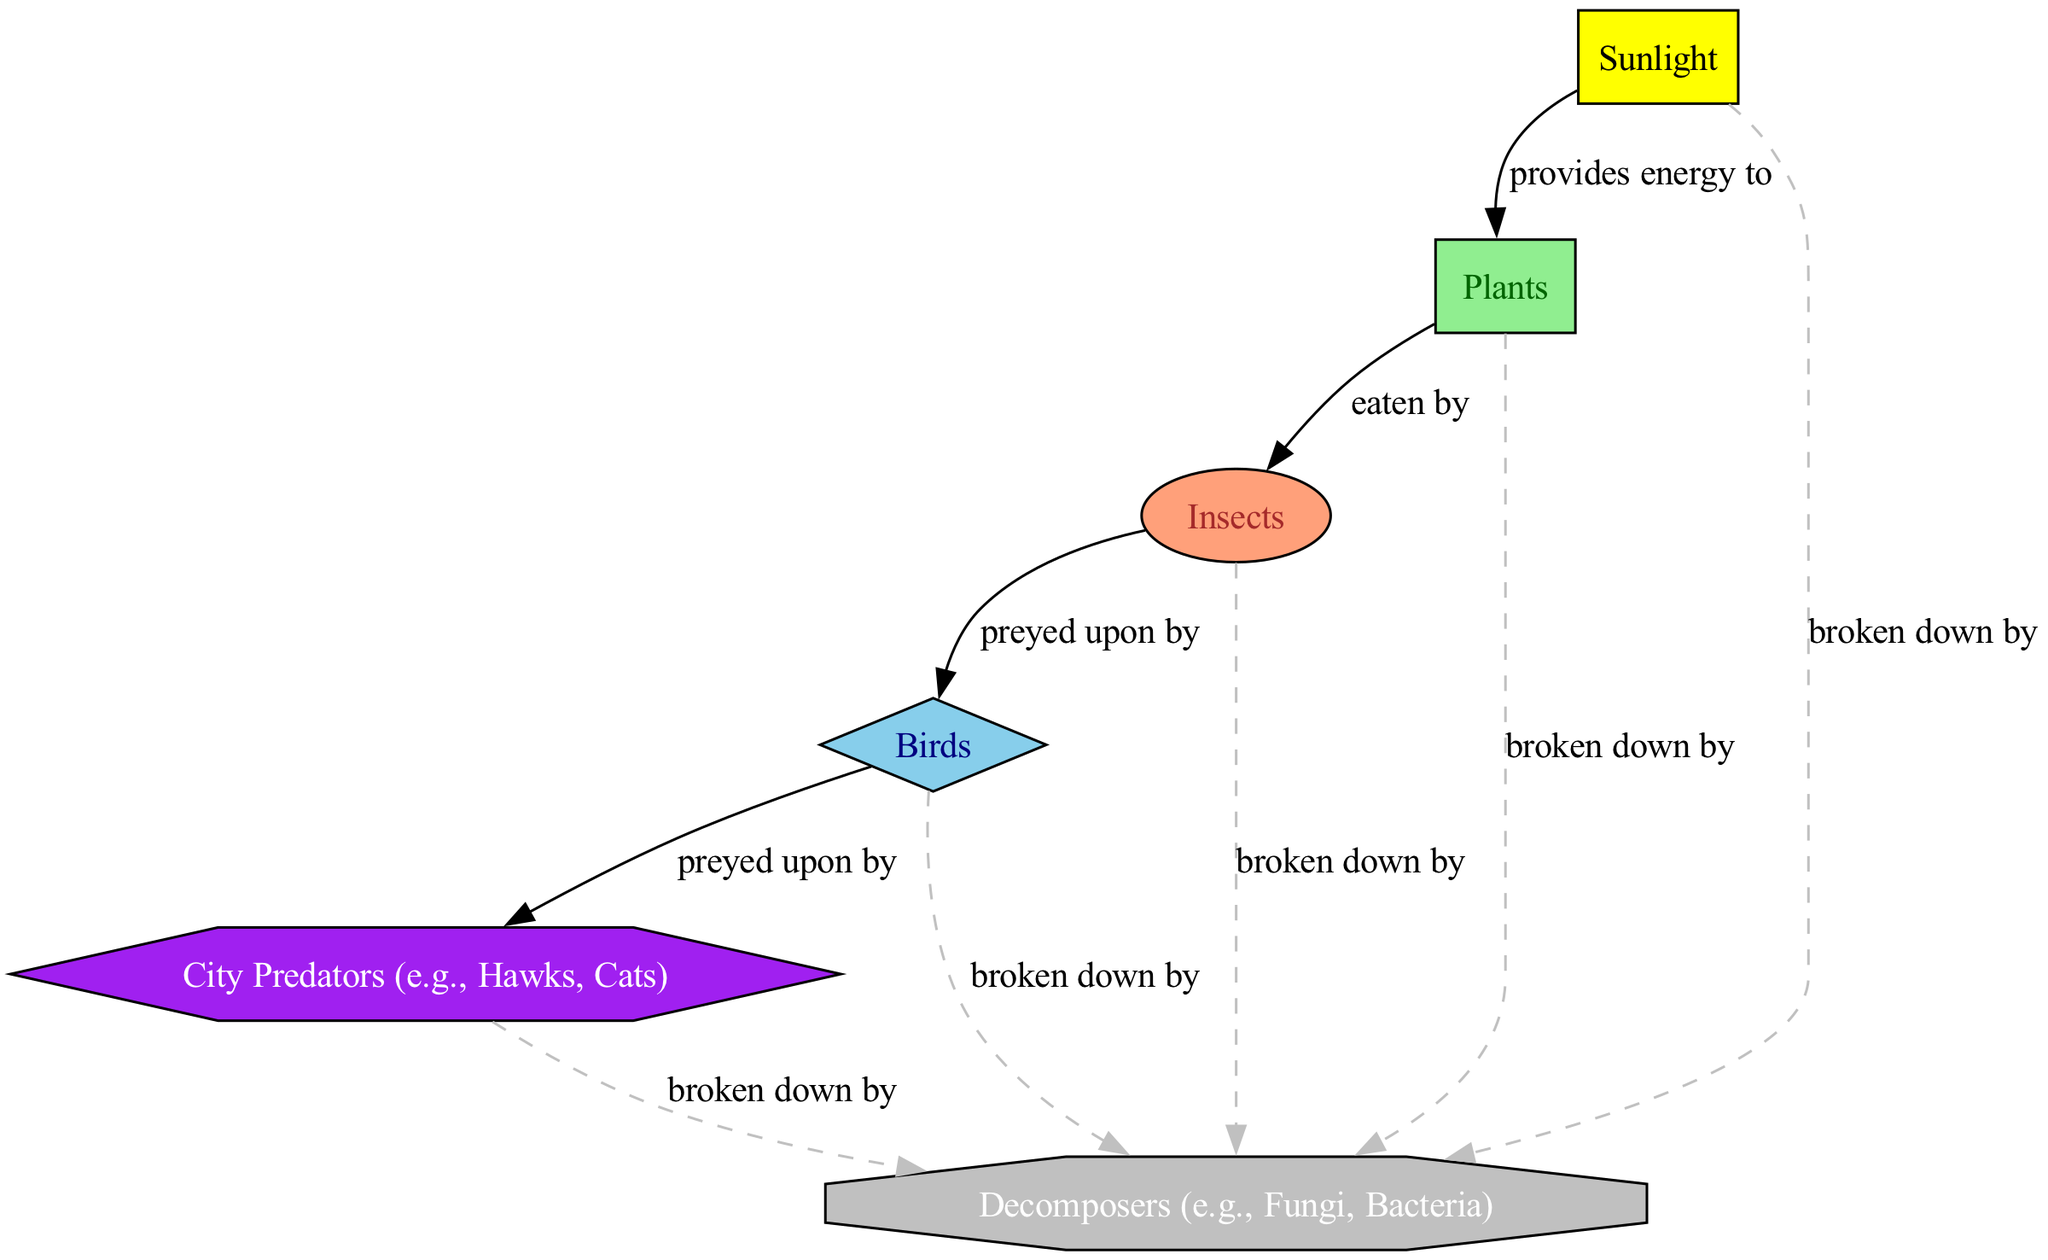What is the primary producer in the urban ecosystem? The primary producer is identified in the diagram where it is the first node connected to the sunlight node, which provides energy. The node labeled "Plants" represents this producer.
Answer: Plants How many nodes are represented in the food chain? By counting each unique circle or shape in the diagram, we identify six nodes: sunlight, plants, insects, birds, city predators, and decomposers. The total is six.
Answer: 6 What type of consumer are insects classified as? Insects are positioned in the diagram where they directly receive energy from the producers, indicating their role. They are labeled as "primary consumer," which determines their classification.
Answer: primary consumer Who preys upon birds in the urban food chain? The diagram shows a direct connection from the birds node to the city predators node, indicating that birds are preyed upon by city predators. This relationship is labeled specifically in the diagram.
Answer: City Predators (e.g., Hawks, Cats) What role do decomposers play in the urban ecosystem? The diagram indicates that all elements break down by decomposers, representing their crucial role in the ecosystem. Decomposers like fungi and bacteria help recycle nutrients back into the soil.
Answer: Decomposers (e.g., Fungi, Bacteria) What energy source do plants rely on? The first node in the diagram is sunlight, which provides energy to the plants. This relationship is clearly depicted with a directed edge connecting sunlight to plants.
Answer: Sunlight What type of consumer are city predators? The position and label of the city predators node in the diagram classify them distinctly. They are connected to secondary consumers and thus represent a higher trophic level. This classification aligns with the diagram structure.
Answer: tertiary consumer How many edges are there in the diagram? By examining the connections between the nodes, we can count the directed edges that describe the relationships. There are five distinct connections represented in the diagram.
Answer: 5 What do all living organisms break down into? The diagram clearly indicates through a connection labeled "broken down by" to the decomposers node that all in the food chain ultimately lead to decomposers for nutrient recycling.
Answer: Decomposers (e.g., Fungi, Bacteria) 